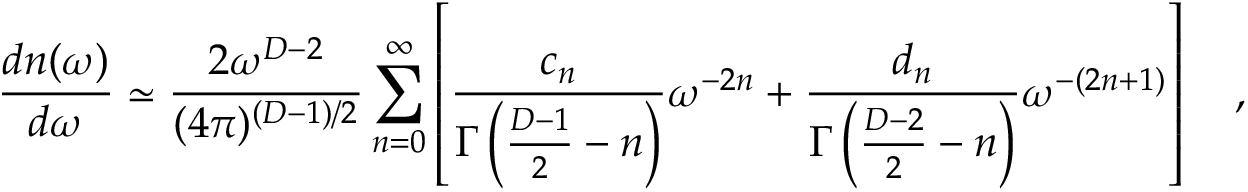Convert formula to latex. <formula><loc_0><loc_0><loc_500><loc_500>{ \frac { d n ( \omega ) } { d \omega } } \simeq { \frac { 2 \omega ^ { D - 2 } } { ( 4 \pi ) ^ { ( D - 1 ) / 2 } } } \sum _ { n = 0 } ^ { \infty } \left [ { \frac { c _ { n } } { \Gamma \left ( { \frac { D - 1 } { 2 } } - n \right ) } } \omega ^ { - 2 n } + { \frac { d _ { n } } { \Gamma \left ( { \frac { D - 2 } { 2 } } - n \right ) } } \omega ^ { - ( 2 n + 1 ) } \right ] ,</formula> 